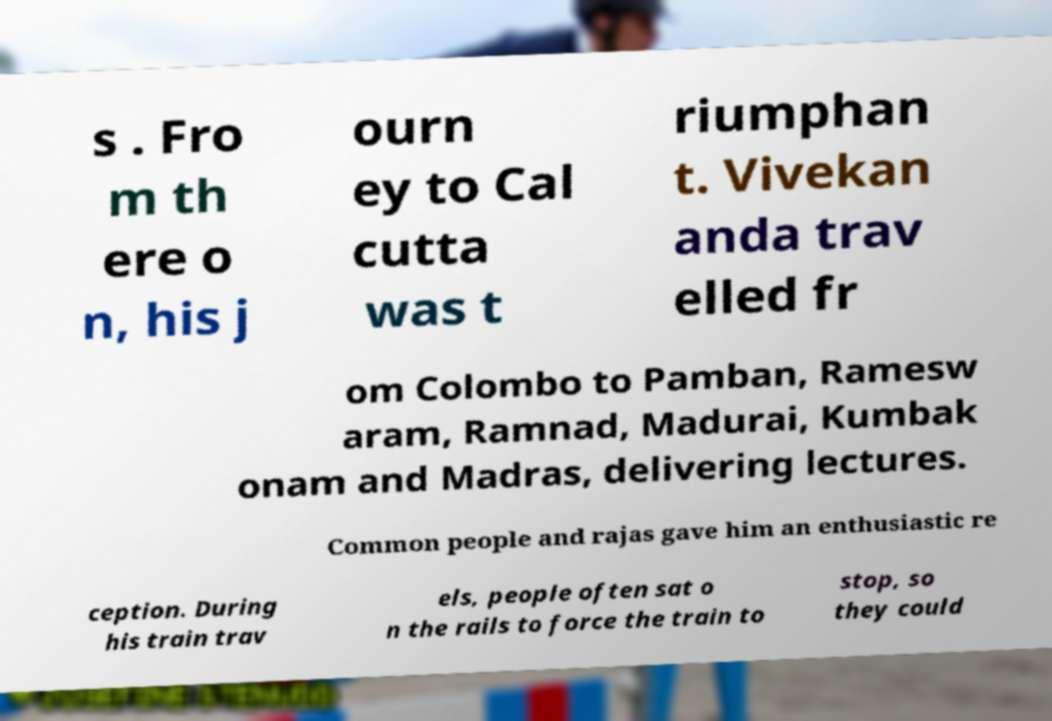Can you accurately transcribe the text from the provided image for me? s . Fro m th ere o n, his j ourn ey to Cal cutta was t riumphan t. Vivekan anda trav elled fr om Colombo to Pamban, Ramesw aram, Ramnad, Madurai, Kumbak onam and Madras, delivering lectures. Common people and rajas gave him an enthusiastic re ception. During his train trav els, people often sat o n the rails to force the train to stop, so they could 